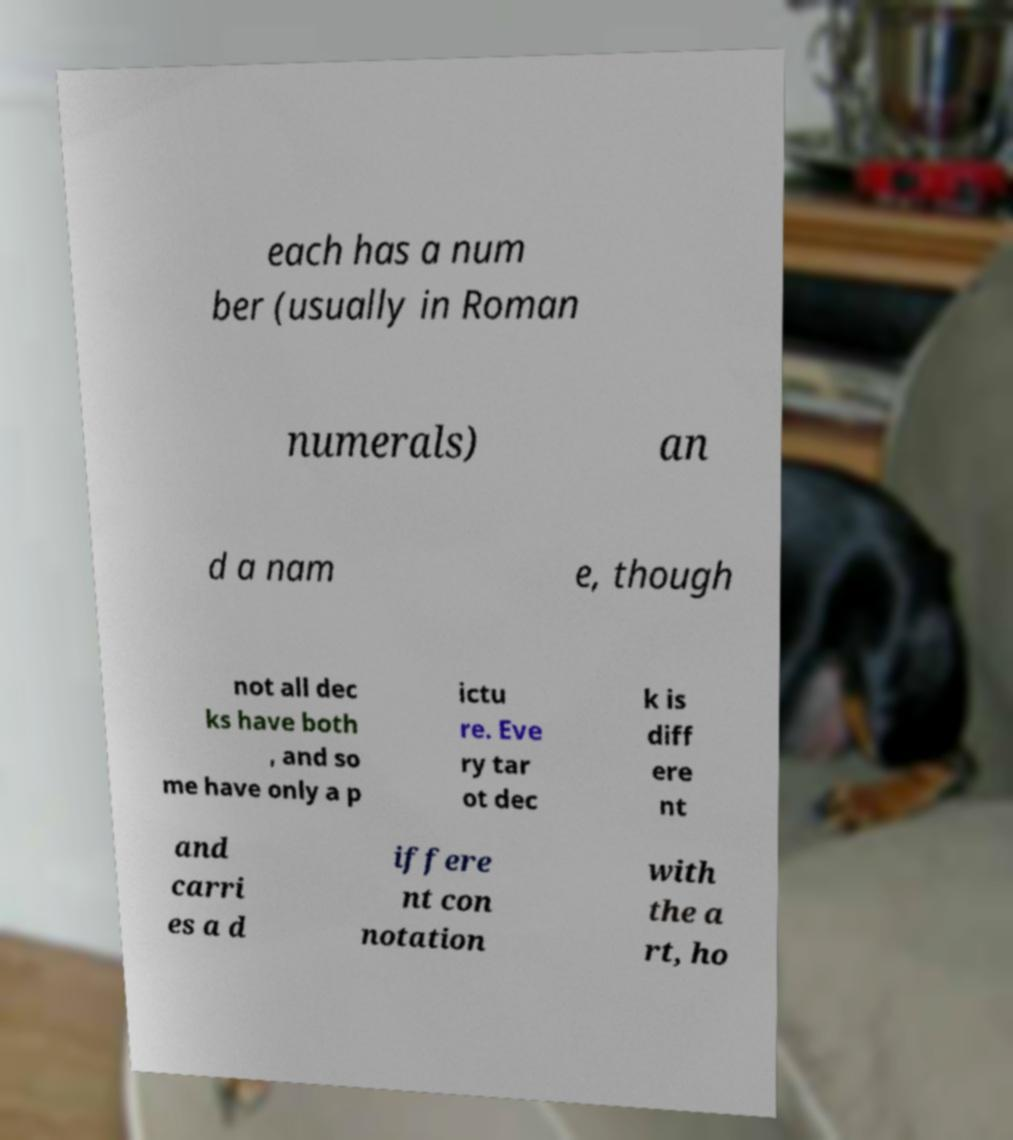Please identify and transcribe the text found in this image. each has a num ber (usually in Roman numerals) an d a nam e, though not all dec ks have both , and so me have only a p ictu re. Eve ry tar ot dec k is diff ere nt and carri es a d iffere nt con notation with the a rt, ho 